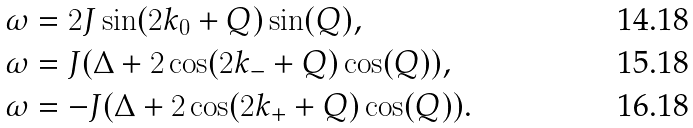<formula> <loc_0><loc_0><loc_500><loc_500>\omega & = 2 J \sin ( 2 k _ { 0 } + Q ) \sin ( Q ) , \\ \omega & = J ( \Delta + 2 \cos ( 2 k _ { - } + Q ) \cos ( Q ) ) , \\ \omega & = - J ( \Delta + 2 \cos ( 2 k _ { + } + Q ) \cos ( Q ) ) .</formula> 